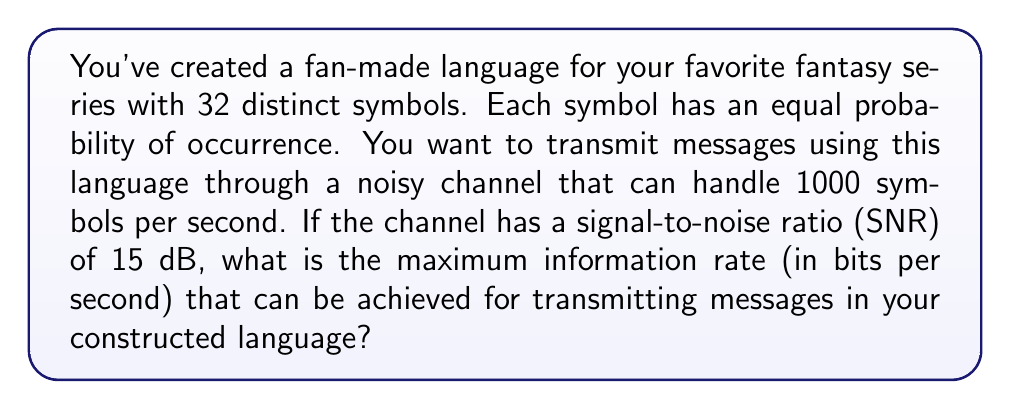What is the answer to this math problem? To solve this problem, we'll use the Shannon-Hartley theorem and the properties of the constructed language. Let's break it down step-by-step:

1. First, we need to calculate the entropy of the language:
   The language has 32 symbols with equal probability, so the entropy is:
   $$H = -\sum_{i=1}^{32} p_i \log_2(p_i) = -32 \cdot \frac{1}{32} \log_2(\frac{1}{32}) = \log_2(32) = 5 \text{ bits/symbol}$$

2. Now, we'll use the Shannon-Hartley theorem to calculate the channel capacity:
   $$C = B \log_2(1 + \text{SNR})$$
   Where:
   $C$ is the channel capacity in bits per second
   $B$ is the bandwidth in Hz (in this case, symbols per second)
   SNR is the signal-to-noise ratio

3. We need to convert the SNR from dB to a linear scale:
   $$\text{SNR}_{\text{linear}} = 10^{\frac{\text{SNR}_{\text{dB}}}{10}} = 10^{\frac{15}{10}} = 31.6228$$

4. Now we can calculate the channel capacity:
   $$C = 1000 \log_2(1 + 31.6228) = 1000 \log_2(32.6228) \approx 5004.33 \text{ bits/second}$$

5. The maximum information rate is the minimum of the channel capacity and the rate at which we can transmit symbols multiplied by the entropy per symbol:
   $$\text{Max Rate} = \min(C, 1000 \text{ symbols/second} \cdot 5 \text{ bits/symbol})$$
   $$\text{Max Rate} = \min(5004.33, 5000) = 5000 \text{ bits/second}$$

Therefore, the maximum information rate that can be achieved for transmitting messages in your constructed language is 5000 bits per second.
Answer: 5000 bits per second 